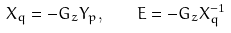Convert formula to latex. <formula><loc_0><loc_0><loc_500><loc_500>X _ { q } = - G _ { z } Y _ { p } , \quad E = - G _ { z } X ^ { - 1 } _ { q }</formula> 